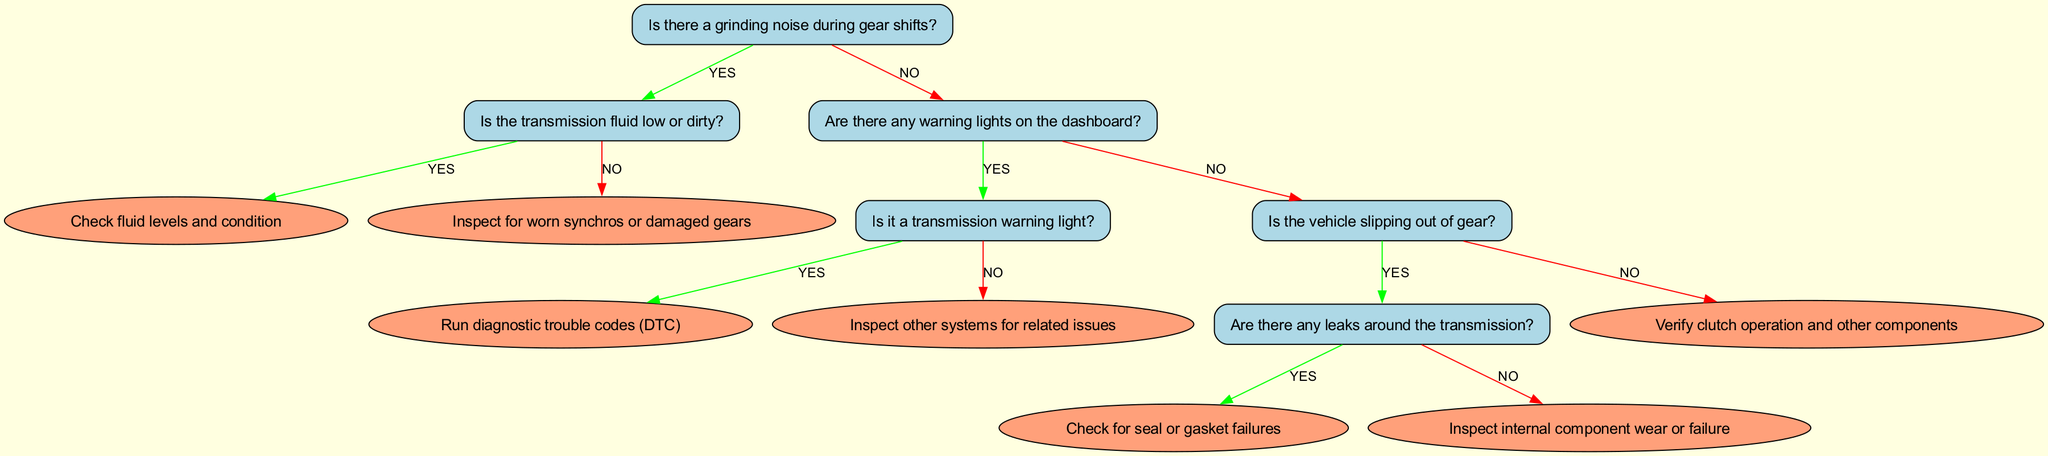Is there a node that addresses the condition of transmission fluid? Yes, the node with ID "2" asks if the transmission fluid is low or dirty. This directly relates to whether there are grinding noises during gear shifts.
Answer: Yes How many total nodes are present in the diagram? The diagram contains six nodes in total, representing different questions and outcomes regarding gearbox problems.
Answer: Six What do you check for after identifying a grinding noise and confirming the fluid condition is good? After confirming that the transmission fluid is not low or dirty, the next step is to inspect for worn synchros or damaged gears, as indicated in node "2".
Answer: Inspect for worn synchros or damaged gears If there are warning lights on the dashboard, what is the next question to address? If there are warning lights (node "3"), the next question is whether the warning light is a transmission warning light (node "4"). This determines the diagnostic steps following the identification of dashboard alerts.
Answer: Is it a transmission warning light? What action is suggested if the vehicle is slipping out of gear? If the vehicle is slipping out of gear (node "5"), the next step is to check for leaks around the transmission in node "6" to further diagnose the issue.
Answer: Check for leaks around the transmission What happens if there is no dashboard warning light but the vehicle is slipping out of gear? If there is no dashboard warning light and the vehicle is slipping out of gear, the next step is to verify clutch operation and other components as stated in node "5".
Answer: Verify clutch operation and other components In the case of a transmission warning light, what should be done next? If it is determined to be a transmission warning light after confirming there is one, the next step is to run diagnostic trouble codes (DTC) based on node "4".
Answer: Run diagnostic trouble codes What might you conclude if the transmission fluid is low or dirty? If the transmission fluid is identified as low or dirty (node "2"), the logical conclusion is to check fluid levels and condition before proceeding further.
Answer: Check fluid levels and condition 